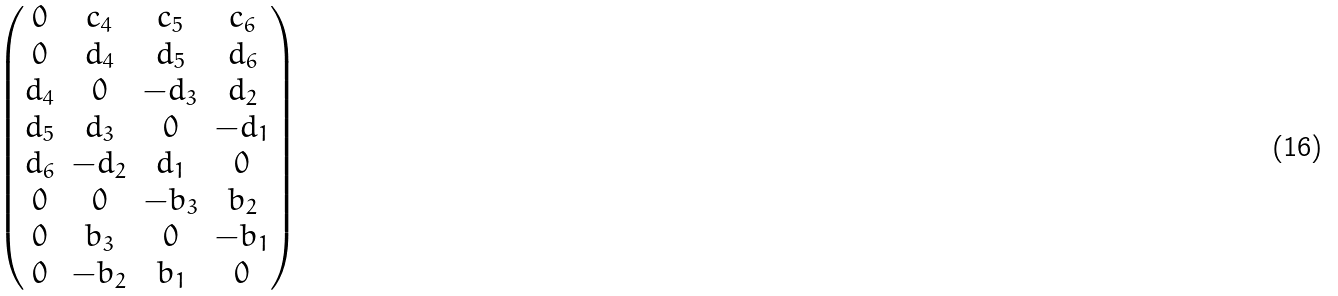<formula> <loc_0><loc_0><loc_500><loc_500>\begin{pmatrix} 0 & c _ { 4 } & c _ { 5 } & c _ { 6 } \\ 0 & d _ { 4 } & d _ { 5 } & d _ { 6 } \\ d _ { 4 } & 0 & - d _ { 3 } & d _ { 2 } \\ d _ { 5 } & d _ { 3 } & 0 & - d _ { 1 } \\ d _ { 6 } & - d _ { 2 } & d _ { 1 } & 0 \\ 0 & 0 & - b _ { 3 } & b _ { 2 } \\ 0 & b _ { 3 } & 0 & - b _ { 1 } \\ 0 & - b _ { 2 } & b _ { 1 } & 0 \\ \end{pmatrix}</formula> 